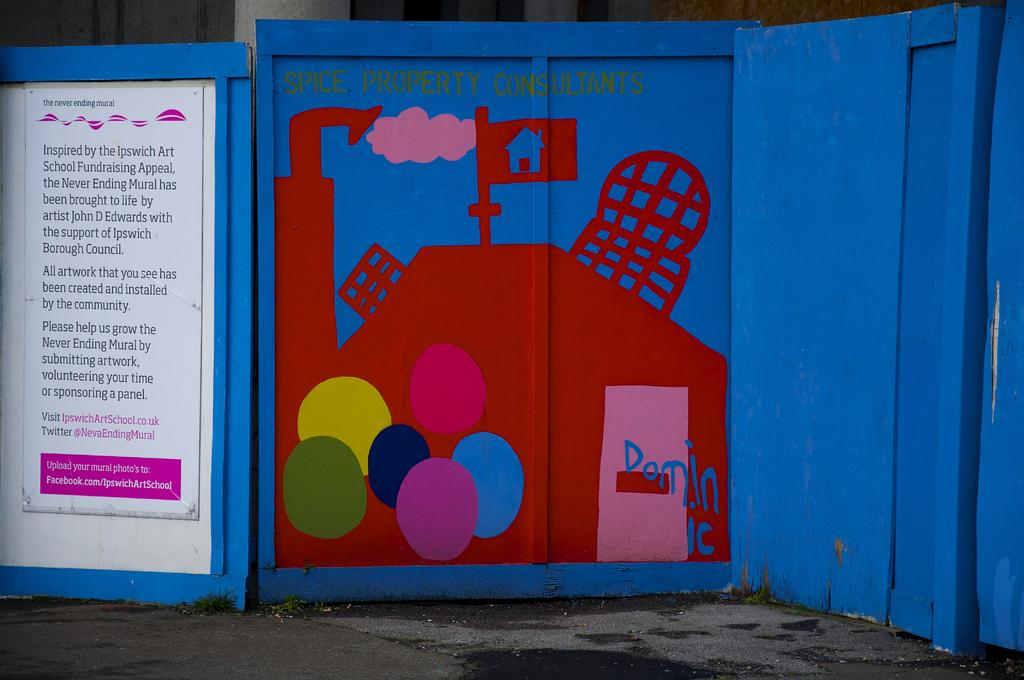<image>
Relay a brief, clear account of the picture shown. A painted wooden sign that reads Spice Property Consultants. 